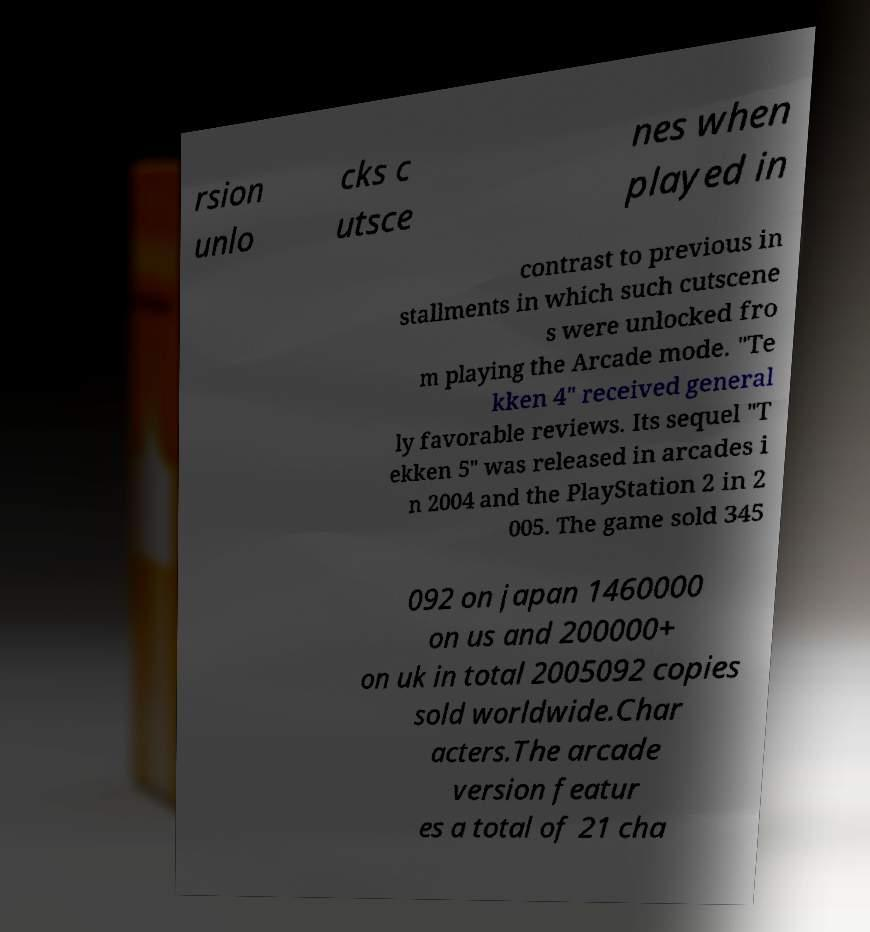For documentation purposes, I need the text within this image transcribed. Could you provide that? rsion unlo cks c utsce nes when played in contrast to previous in stallments in which such cutscene s were unlocked fro m playing the Arcade mode. "Te kken 4" received general ly favorable reviews. Its sequel "T ekken 5" was released in arcades i n 2004 and the PlayStation 2 in 2 005. The game sold 345 092 on japan 1460000 on us and 200000+ on uk in total 2005092 copies sold worldwide.Char acters.The arcade version featur es a total of 21 cha 